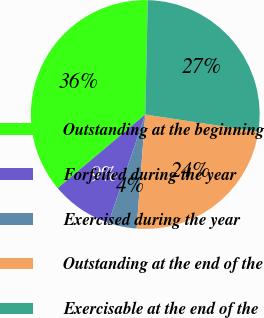Convert chart to OTSL. <chart><loc_0><loc_0><loc_500><loc_500><pie_chart><fcel>Outstanding at the beginning<fcel>Forfeited during the year<fcel>Exercised during the year<fcel>Outstanding at the end of the<fcel>Exercisable at the end of the<nl><fcel>36.48%<fcel>8.67%<fcel>4.0%<fcel>23.8%<fcel>27.05%<nl></chart> 